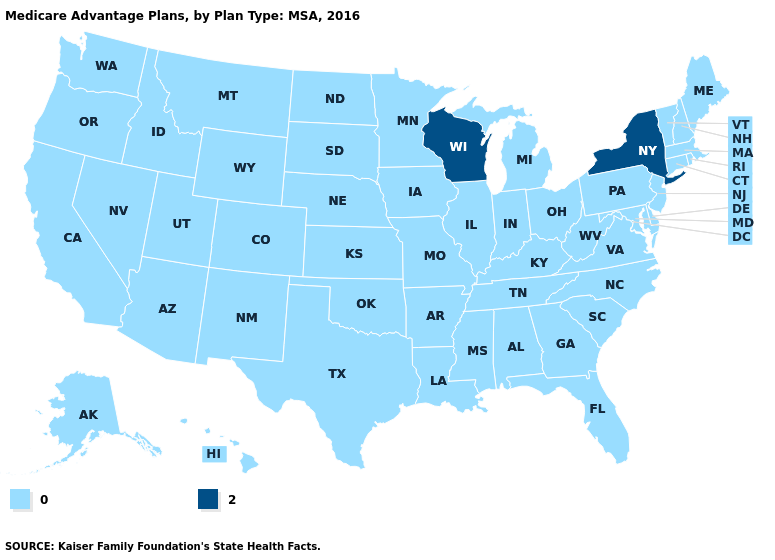What is the value of Wisconsin?
Answer briefly. 2. What is the lowest value in the USA?
Answer briefly. 0. Does Wisconsin have the lowest value in the USA?
Answer briefly. No. What is the value of Massachusetts?
Keep it brief. 0. Which states have the highest value in the USA?
Give a very brief answer. New York, Wisconsin. What is the lowest value in states that border New Hampshire?
Quick response, please. 0. Among the states that border Massachusetts , which have the highest value?
Short answer required. New York. Does Massachusetts have the highest value in the Northeast?
Concise answer only. No. Does Montana have the highest value in the USA?
Be succinct. No. What is the value of Utah?
Answer briefly. 0. Name the states that have a value in the range 2?
Keep it brief. New York, Wisconsin. What is the highest value in the USA?
Concise answer only. 2. Name the states that have a value in the range 0?
Concise answer only. Alaska, Alabama, Arkansas, Arizona, California, Colorado, Connecticut, Delaware, Florida, Georgia, Hawaii, Iowa, Idaho, Illinois, Indiana, Kansas, Kentucky, Louisiana, Massachusetts, Maryland, Maine, Michigan, Minnesota, Missouri, Mississippi, Montana, North Carolina, North Dakota, Nebraska, New Hampshire, New Jersey, New Mexico, Nevada, Ohio, Oklahoma, Oregon, Pennsylvania, Rhode Island, South Carolina, South Dakota, Tennessee, Texas, Utah, Virginia, Vermont, Washington, West Virginia, Wyoming. What is the value of Connecticut?
Be succinct. 0. Name the states that have a value in the range 0?
Concise answer only. Alaska, Alabama, Arkansas, Arizona, California, Colorado, Connecticut, Delaware, Florida, Georgia, Hawaii, Iowa, Idaho, Illinois, Indiana, Kansas, Kentucky, Louisiana, Massachusetts, Maryland, Maine, Michigan, Minnesota, Missouri, Mississippi, Montana, North Carolina, North Dakota, Nebraska, New Hampshire, New Jersey, New Mexico, Nevada, Ohio, Oklahoma, Oregon, Pennsylvania, Rhode Island, South Carolina, South Dakota, Tennessee, Texas, Utah, Virginia, Vermont, Washington, West Virginia, Wyoming. 